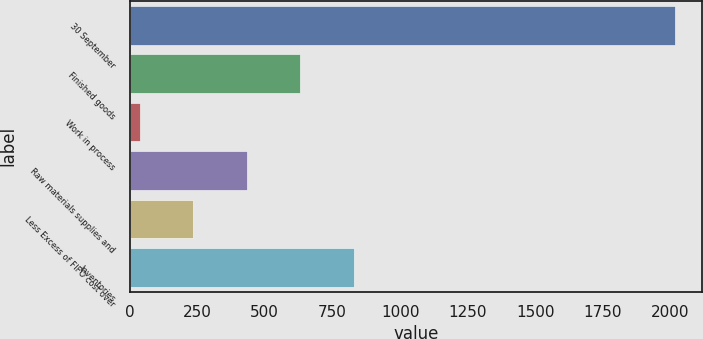<chart> <loc_0><loc_0><loc_500><loc_500><bar_chart><fcel>30 September<fcel>Finished goods<fcel>Work in process<fcel>Raw materials supplies and<fcel>Less Excess of FIFO cost over<fcel>Inventories<nl><fcel>2016<fcel>631.54<fcel>38.2<fcel>433.76<fcel>235.98<fcel>829.32<nl></chart> 